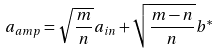<formula> <loc_0><loc_0><loc_500><loc_500>a _ { a m p } = \sqrt { \frac { m } { n } } a _ { i n } + \sqrt { \frac { m - n } { n } } b ^ { * }</formula> 